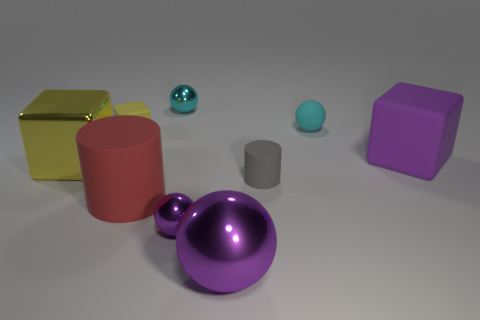Add 1 yellow cubes. How many objects exist? 10 Subtract all blocks. How many objects are left? 6 Subtract all gray cubes. Subtract all tiny yellow cubes. How many objects are left? 8 Add 5 small metallic balls. How many small metallic balls are left? 7 Add 4 tiny purple matte balls. How many tiny purple matte balls exist? 4 Subtract 0 red cubes. How many objects are left? 9 